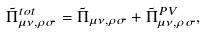Convert formula to latex. <formula><loc_0><loc_0><loc_500><loc_500>\tilde { \Pi } ^ { t o t } _ { \mu \nu , \rho \sigma } = \tilde { \Pi } _ { \mu \nu , \rho \sigma } + \tilde { \Pi } ^ { P V } _ { \mu \nu , \rho \sigma } ,</formula> 